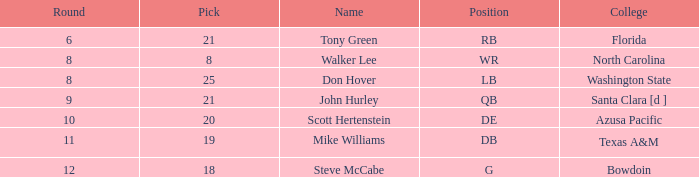Can you parse all the data within this table? {'header': ['Round', 'Pick', 'Name', 'Position', 'College'], 'rows': [['6', '21', 'Tony Green', 'RB', 'Florida'], ['8', '8', 'Walker Lee', 'WR', 'North Carolina'], ['8', '25', 'Don Hover', 'LB', 'Washington State'], ['9', '21', 'John Hurley', 'QB', 'Santa Clara [d ]'], ['10', '20', 'Scott Hertenstein', 'DE', 'Azusa Pacific'], ['11', '19', 'Mike Williams', 'DB', 'Texas A&M'], ['12', '18', 'Steve McCabe', 'G', 'Bowdoin']]} In which college is the name tony green and the overall score is less than 243? Florida. 